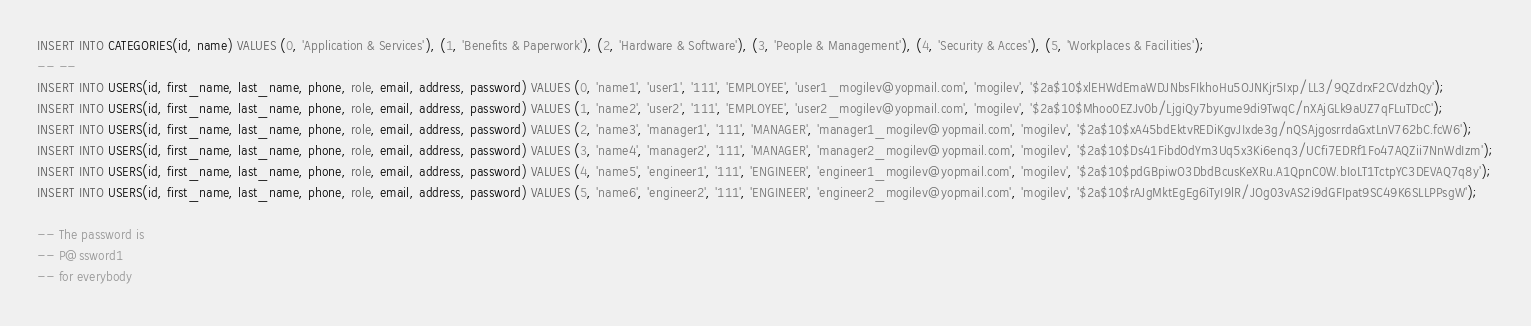Convert code to text. <code><loc_0><loc_0><loc_500><loc_500><_SQL_>INSERT INTO CATEGORIES(id, name) VALUES (0, 'Application & Services'), (1, 'Benefits & Paperwork'), (2, 'Hardware & Software'), (3, 'People & Management'), (4, 'Security & Acces'), (5, 'Workplaces & Facilities');
-- --
INSERT INTO USERS(id, first_name, last_name, phone, role, email, address, password) VALUES (0, 'name1', 'user1', '111', 'EMPLOYEE', 'user1_mogilev@yopmail.com', 'mogilev', '$2a$10$xlEHWdEmaWDJNbsFIkhoHu5OJNKjr5Ixp/LL3/9QZdrxF2CVdzhQy');
INSERT INTO USERS(id, first_name, last_name, phone, role, email, address, password) VALUES (1, 'name2', 'user2', '111', 'EMPLOYEE', 'user2_mogilev@yopmail.com', 'mogilev', '$2a$10$Mhoo0EZJv0b/LjgiQy7byume9di9TwqC/nXAjGLk9aUZ7qFLuTDcC');
INSERT INTO USERS(id, first_name, last_name, phone, role, email, address, password) VALUES (2, 'name3', 'manager1', '111', 'MANAGER', 'manager1_mogilev@yopmail.com', 'mogilev', '$2a$10$xA45bdEktvREDiKgvJIxde3g/nQSAjgosrrdaGxtLnV762bC.fcW6');
INSERT INTO USERS(id, first_name, last_name, phone, role, email, address, password) VALUES (3, 'name4', 'manager2', '111', 'MANAGER', 'manager2_mogilev@yopmail.com', 'mogilev', '$2a$10$Ds41FibdOdYm3Uq5x3Ki6enq3/UCfi7EDRf1Fo47AQZii7NnWdIzm');
INSERT INTO USERS(id, first_name, last_name, phone, role, email, address, password) VALUES (4, 'name5', 'engineer1', '111', 'ENGINEER', 'engineer1_mogilev@yopmail.com', 'mogilev', '$2a$10$pdGBpiwO3DbdBcusKeXRu.A1QpnC0W.bIoLT1TctpYC3DEVAQ7q8y');
INSERT INTO USERS(id, first_name, last_name, phone, role, email, address, password) VALUES (5, 'name6', 'engineer2', '111', 'ENGINEER', 'engineer2_mogilev@yopmail.com', 'mogilev', '$2a$10$rAJgMktEgEg6iTyI9lR/JOg03vAS2i9dGFIpat9SC49K6SLLPPsgW');

-- The password is
-- P@ssword1
-- for everybody</code> 